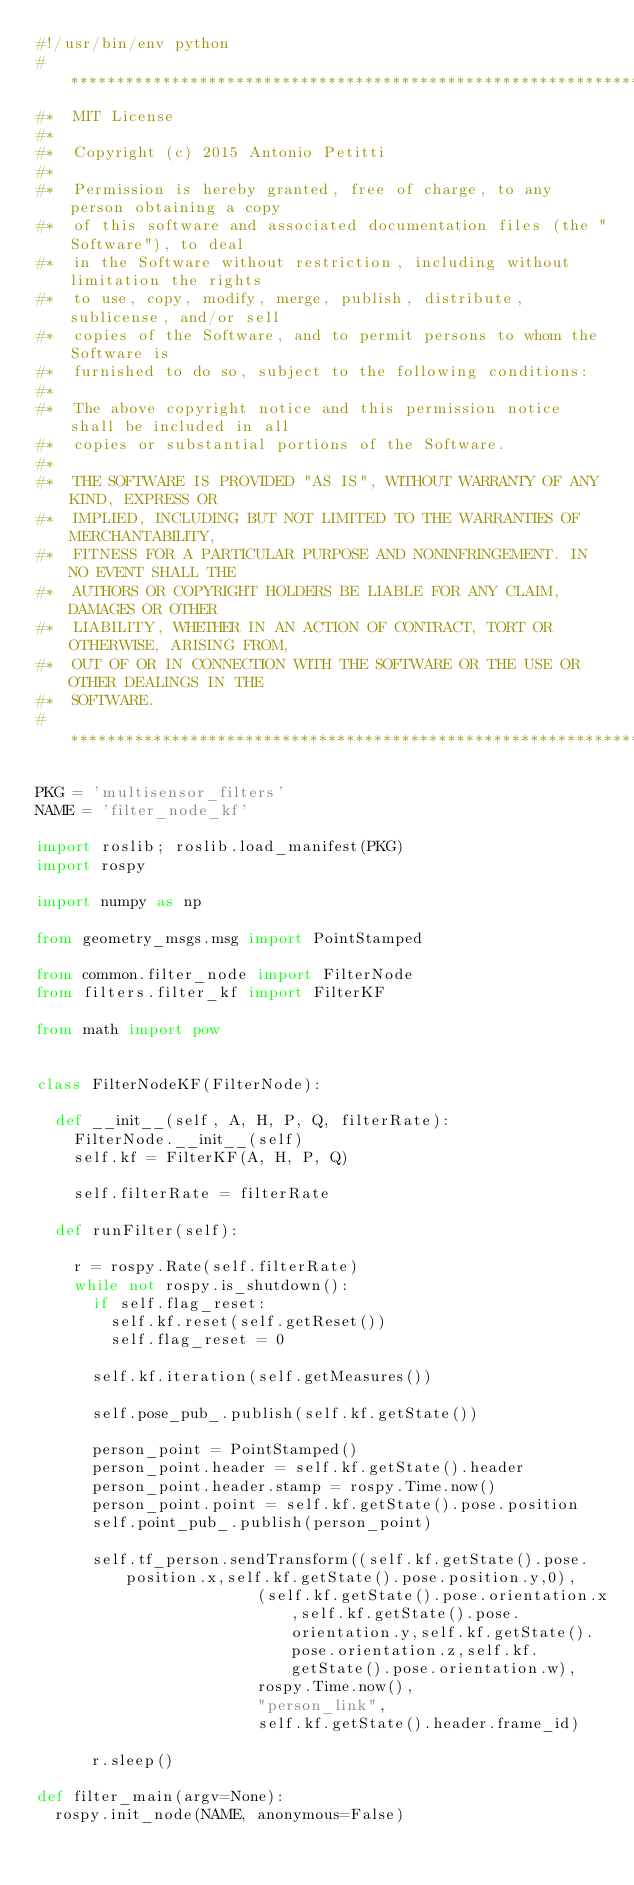Convert code to text. <code><loc_0><loc_0><loc_500><loc_500><_Python_>#!/usr/bin/env python
#*********************************************************************
#*  MIT License
#*
#*  Copyright (c) 2015 Antonio Petitti
#*
#*  Permission is hereby granted, free of charge, to any person obtaining a copy
#*  of this software and associated documentation files (the "Software"), to deal
#*  in the Software without restriction, including without limitation the rights
#*  to use, copy, modify, merge, publish, distribute, sublicense, and/or sell
#*  copies of the Software, and to permit persons to whom the Software is
#*  furnished to do so, subject to the following conditions:
#*  
#*  The above copyright notice and this permission notice shall be included in all
#*  copies or substantial portions of the Software.
#*  
#*  THE SOFTWARE IS PROVIDED "AS IS", WITHOUT WARRANTY OF ANY KIND, EXPRESS OR
#*  IMPLIED, INCLUDING BUT NOT LIMITED TO THE WARRANTIES OF MERCHANTABILITY,
#*  FITNESS FOR A PARTICULAR PURPOSE AND NONINFRINGEMENT. IN NO EVENT SHALL THE
#*  AUTHORS OR COPYRIGHT HOLDERS BE LIABLE FOR ANY CLAIM, DAMAGES OR OTHER
#*  LIABILITY, WHETHER IN AN ACTION OF CONTRACT, TORT OR OTHERWISE, ARISING FROM,
#*  OUT OF OR IN CONNECTION WITH THE SOFTWARE OR THE USE OR OTHER DEALINGS IN THE
#*  SOFTWARE.
#*********************************************************************

PKG = 'multisensor_filters'
NAME = 'filter_node_kf'

import roslib; roslib.load_manifest(PKG)
import rospy

import numpy as np

from geometry_msgs.msg import PointStamped

from common.filter_node import FilterNode
from filters.filter_kf import FilterKF

from math import pow


class FilterNodeKF(FilterNode):
		
	def __init__(self, A, H, P, Q, filterRate):
		FilterNode.__init__(self)
		self.kf = FilterKF(A, H, P, Q)

		self.filterRate = filterRate

	def runFilter(self):

		r = rospy.Rate(self.filterRate) 
		while not rospy.is_shutdown():
			if self.flag_reset:
				self.kf.reset(self.getReset())
				self.flag_reset = 0

			self.kf.iteration(self.getMeasures())

			self.pose_pub_.publish(self.kf.getState())
			
			person_point = PointStamped()
			person_point.header = self.kf.getState().header
			person_point.header.stamp = rospy.Time.now()
			person_point.point = self.kf.getState().pose.position
			self.point_pub_.publish(person_point)

			self.tf_person.sendTransform((self.kf.getState().pose.position.x,self.kf.getState().pose.position.y,0),
                     		(self.kf.getState().pose.orientation.x,self.kf.getState().pose.orientation.y,self.kf.getState().pose.orientation.z,self.kf.getState().pose.orientation.w),
                     		rospy.Time.now(),
                     		"person_link",
                     		self.kf.getState().header.frame_id)

			r.sleep()

def filter_main(argv=None):
	rospy.init_node(NAME, anonymous=False)
</code> 